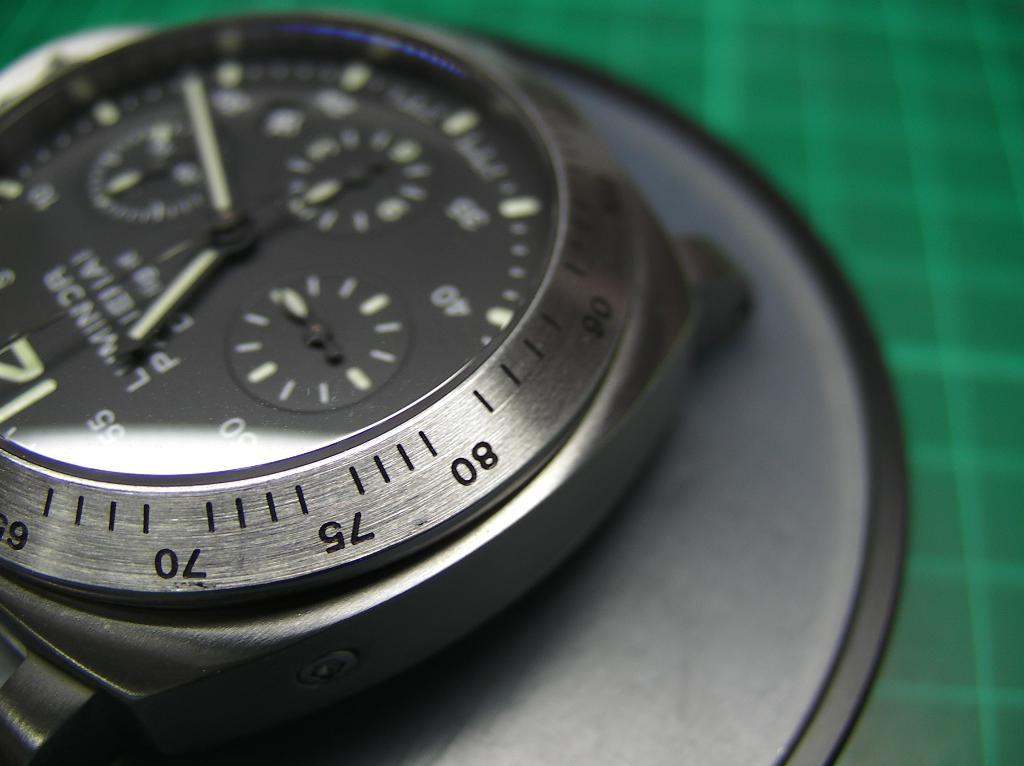<image>
Give a short and clear explanation of the subsequent image. a safe key that has the letters 80 and 75 on it 